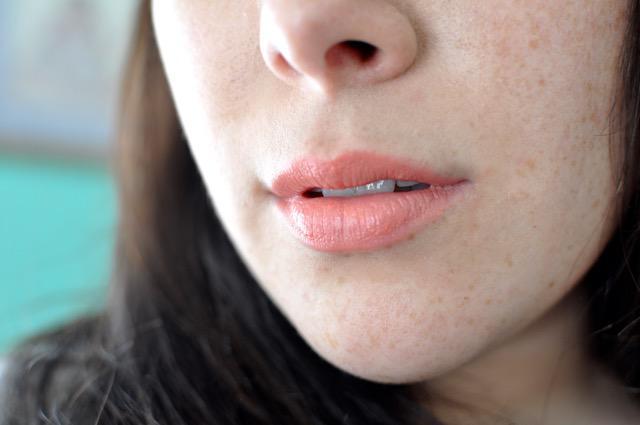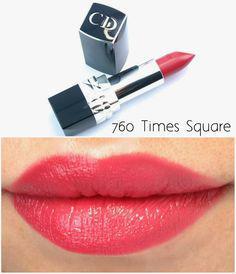The first image is the image on the left, the second image is the image on the right. Evaluate the accuracy of this statement regarding the images: "A pair of lips is shown in each image.". Is it true? Answer yes or no. Yes. The first image is the image on the left, the second image is the image on the right. Given the left and right images, does the statement "There are three lipsticks in the image on the left" hold true? Answer yes or no. No. The first image is the image on the left, the second image is the image on the right. Evaluate the accuracy of this statement regarding the images: "There are at least three containers of lipstick.". Is it true? Answer yes or no. No. 